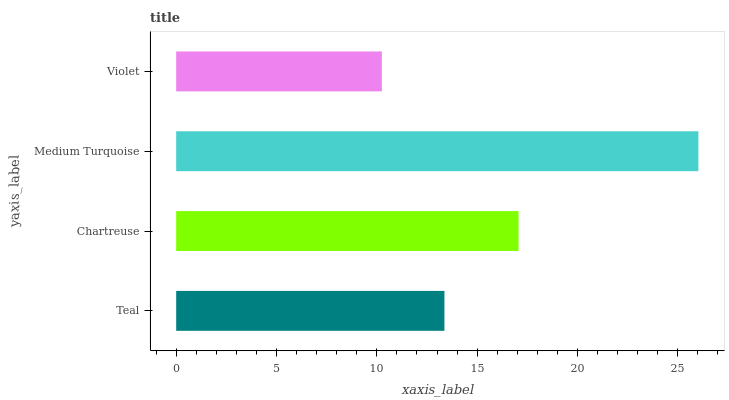Is Violet the minimum?
Answer yes or no. Yes. Is Medium Turquoise the maximum?
Answer yes or no. Yes. Is Chartreuse the minimum?
Answer yes or no. No. Is Chartreuse the maximum?
Answer yes or no. No. Is Chartreuse greater than Teal?
Answer yes or no. Yes. Is Teal less than Chartreuse?
Answer yes or no. Yes. Is Teal greater than Chartreuse?
Answer yes or no. No. Is Chartreuse less than Teal?
Answer yes or no. No. Is Chartreuse the high median?
Answer yes or no. Yes. Is Teal the low median?
Answer yes or no. Yes. Is Medium Turquoise the high median?
Answer yes or no. No. Is Chartreuse the low median?
Answer yes or no. No. 